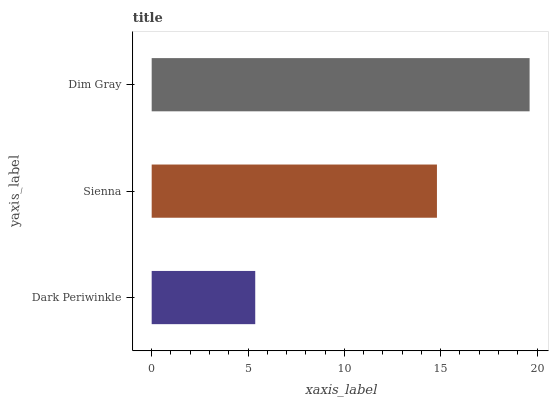Is Dark Periwinkle the minimum?
Answer yes or no. Yes. Is Dim Gray the maximum?
Answer yes or no. Yes. Is Sienna the minimum?
Answer yes or no. No. Is Sienna the maximum?
Answer yes or no. No. Is Sienna greater than Dark Periwinkle?
Answer yes or no. Yes. Is Dark Periwinkle less than Sienna?
Answer yes or no. Yes. Is Dark Periwinkle greater than Sienna?
Answer yes or no. No. Is Sienna less than Dark Periwinkle?
Answer yes or no. No. Is Sienna the high median?
Answer yes or no. Yes. Is Sienna the low median?
Answer yes or no. Yes. Is Dark Periwinkle the high median?
Answer yes or no. No. Is Dark Periwinkle the low median?
Answer yes or no. No. 